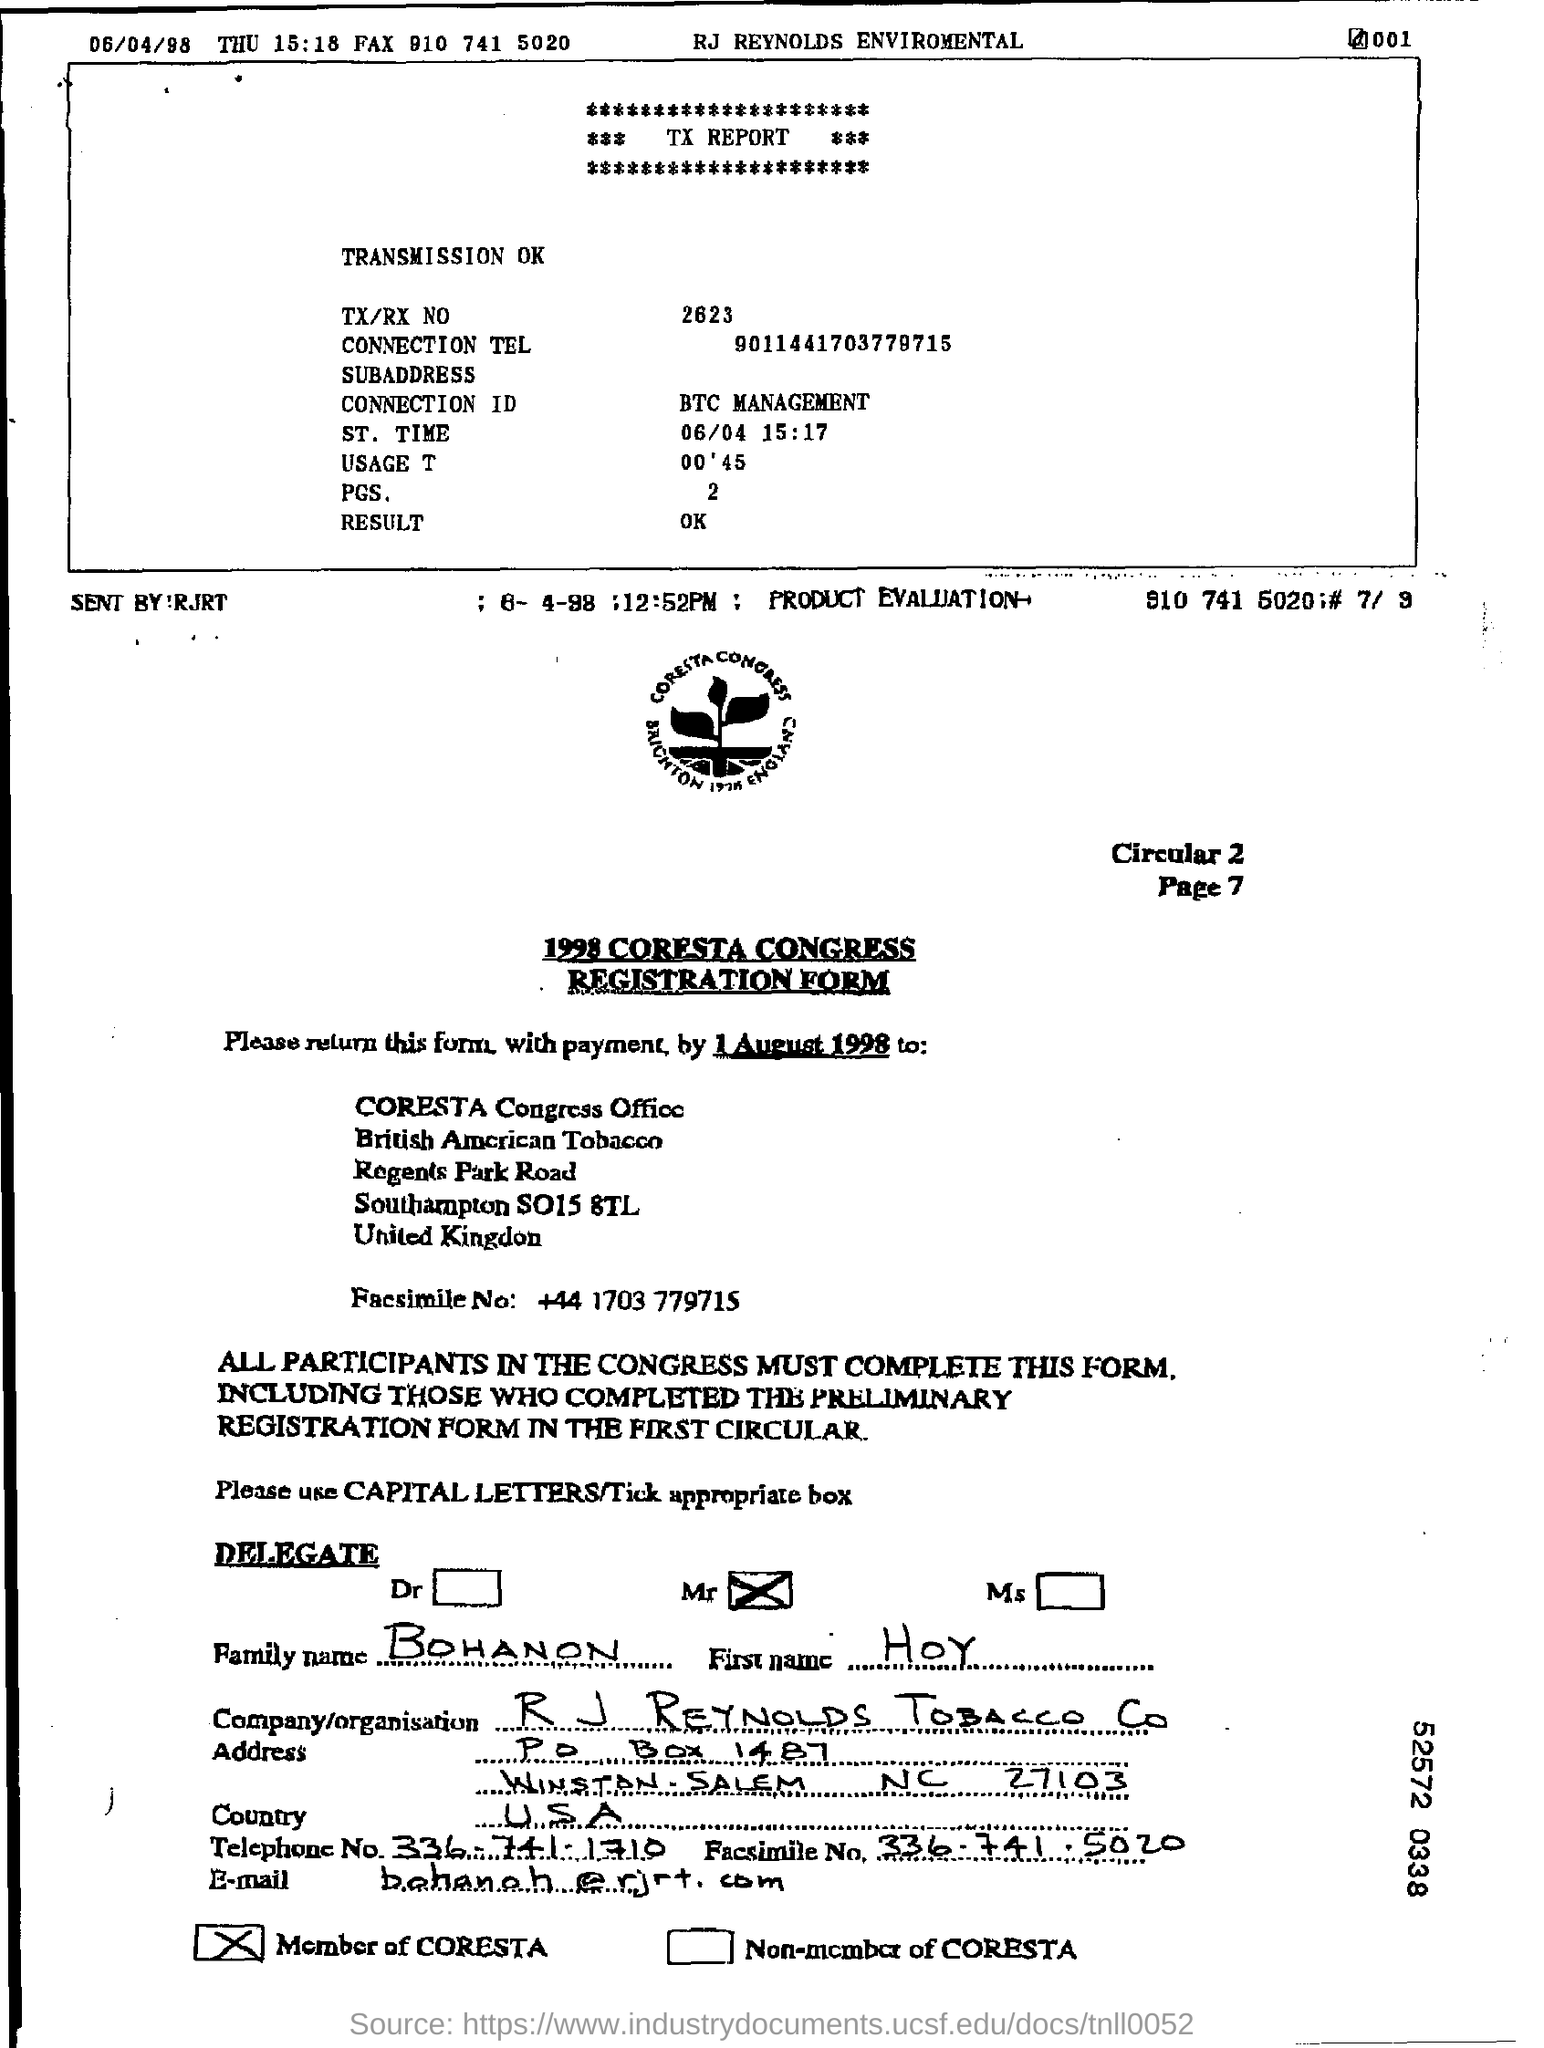Identify some key points in this picture. The TX/RX number is 2623. There are two pages in the report. The telephone number written in the form is 336-741-1710. The registration form contained the country name "USA. The registration form contains the name of a company or organization called R.J. Reynolds Tobacco Company. 